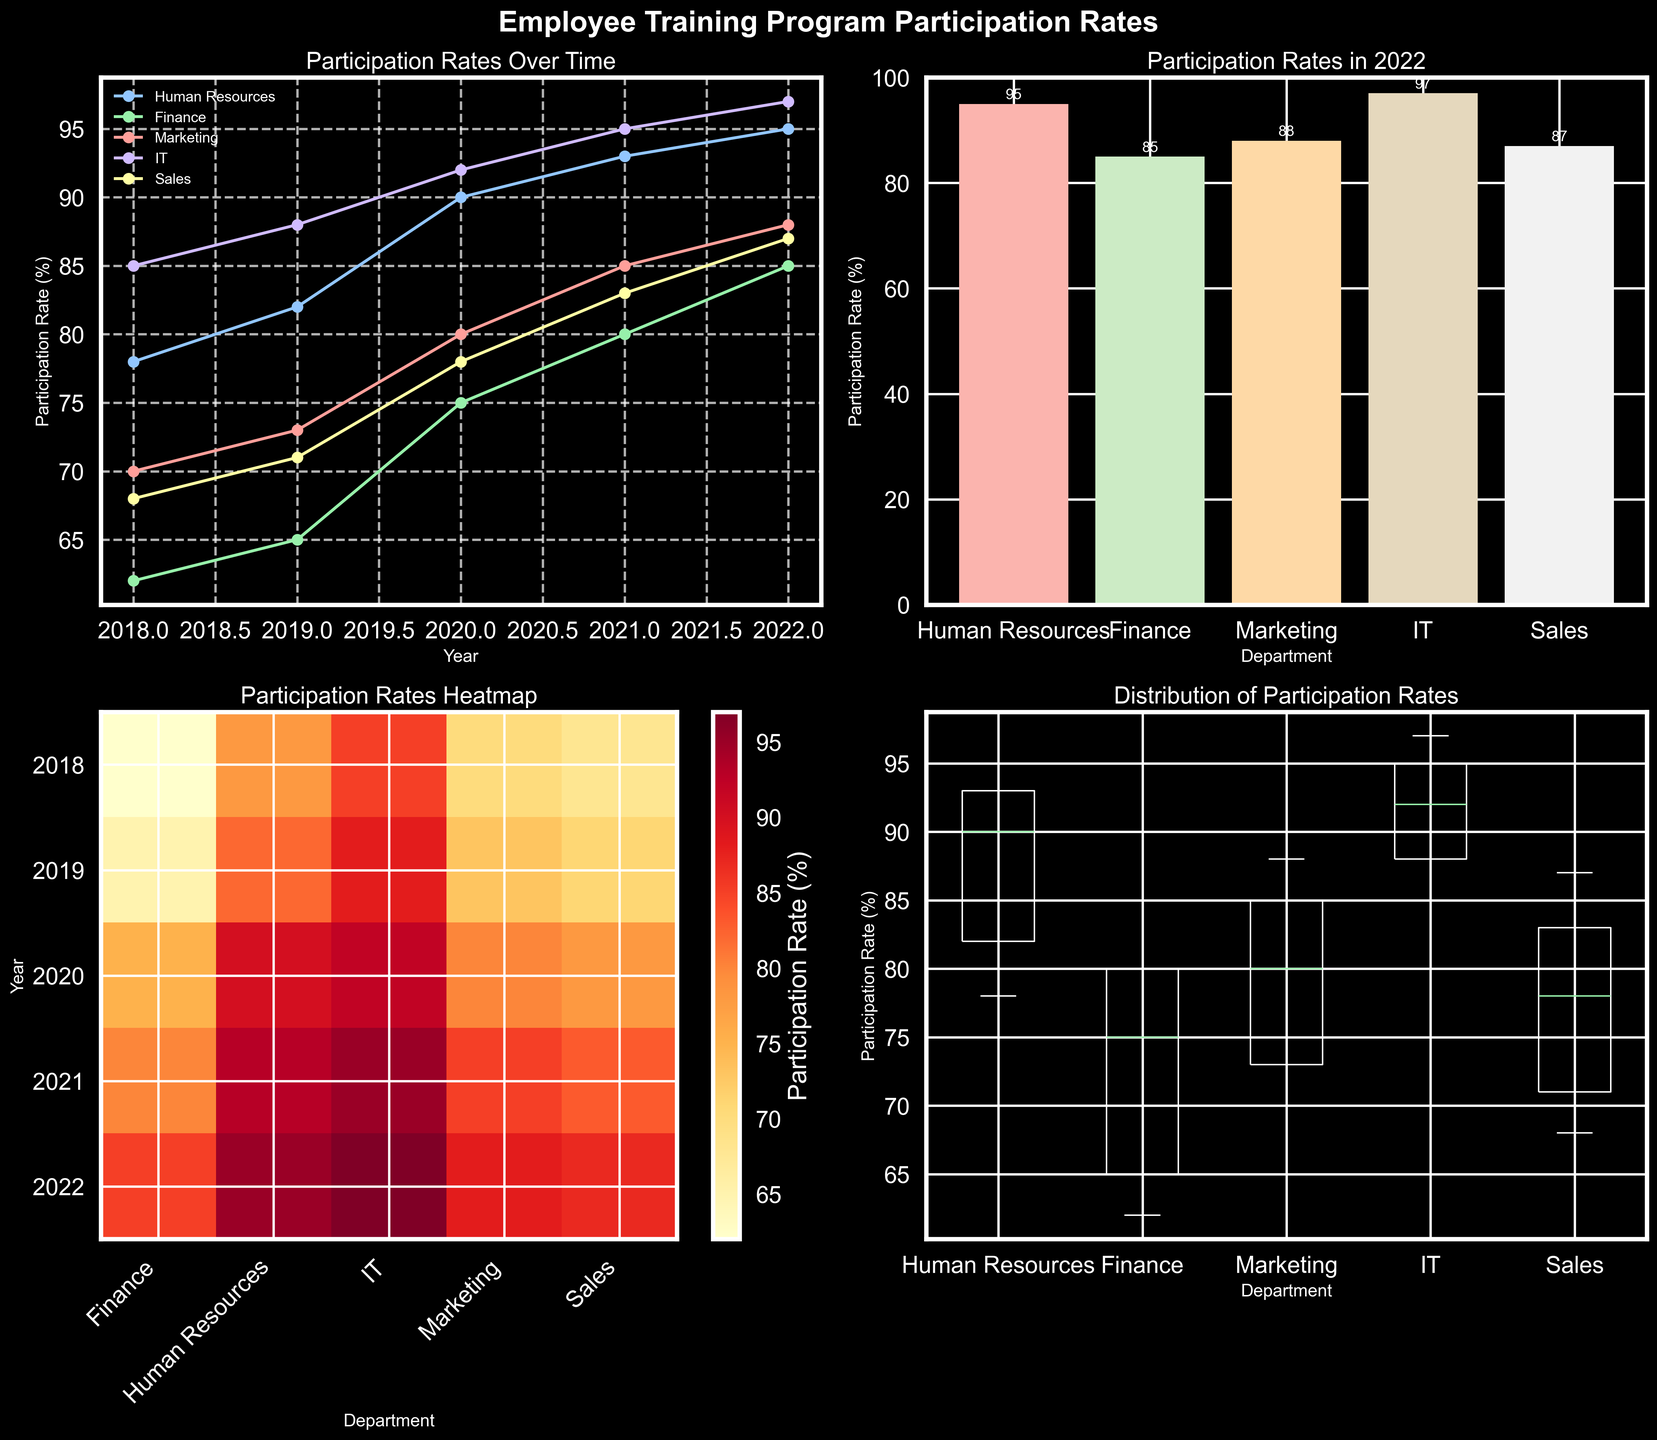what is the title of the figure? The title of the figure is displayed at the top and reads "Employee Training Program Participation Rates". It is written in bold font and is quite prominent.
Answer: Employee Training Program Participation Rates which department has the highest participation rate in 2022? In the bar plot for 2022, the tallest bar represents IT, indicating it has the highest participation rate. The exact value is also displayed above the bar, which is 97%.
Answer: IT how did the participation rate of the Human Resources department change from 2018 to 2022? In the line plot, the Human Resources department's line starts at 78% in 2018 and rises steadily each year, reaching 95% in 2022.
Answer: Increased compare the participation rates of Finance and Marketing in 2021 Both departments' participation rates are shown in the line plot and the heatmap for 2021. Finance has a rate of 80% and Marketing has a rate of 85%.
Answer: Marketing is higher what is the distribution of IT department's participation rates? In the box plot, the IT department's box shows participation rates clustered between approximately 85% and 97%, with no outliers, indicating a consistently high participation rate.
Answer: Between 85% and 97% which department showed the most improvement from 2018 to 2022? By comparing the starting and ending points of each line in the line plot, the Finance department shows an increase from 62% to 85% which is the largest numeric improvement.
Answer: Finance what is the average participation rate for Marketing over the 5 years? Looking at the values from the line plot or heatmap for Marketing (70, 73, 80, 85, 88), sum these up (396) and divide by 5.
Answer: 79.2% which year had the highest overall participation rates across all departments? By evaluating the heatmap, the year 2022 shows the darkest hue across departments, indicating the highest participation rates overall.
Answer: 2022 describe the trend of participation rates in the Sales department In the line plot, the Sales department's participation rate shows a steady increase from 68% in 2018 to 87% in 2022.
Answer: Steady increase why is a heatmap used to show participation rates? A heatmap allows a quick comparison of participation rates across both years and departments. Darker colors indicate higher rates, making it easy to identify trends and areas of high participation.
Answer: Quick comparison 